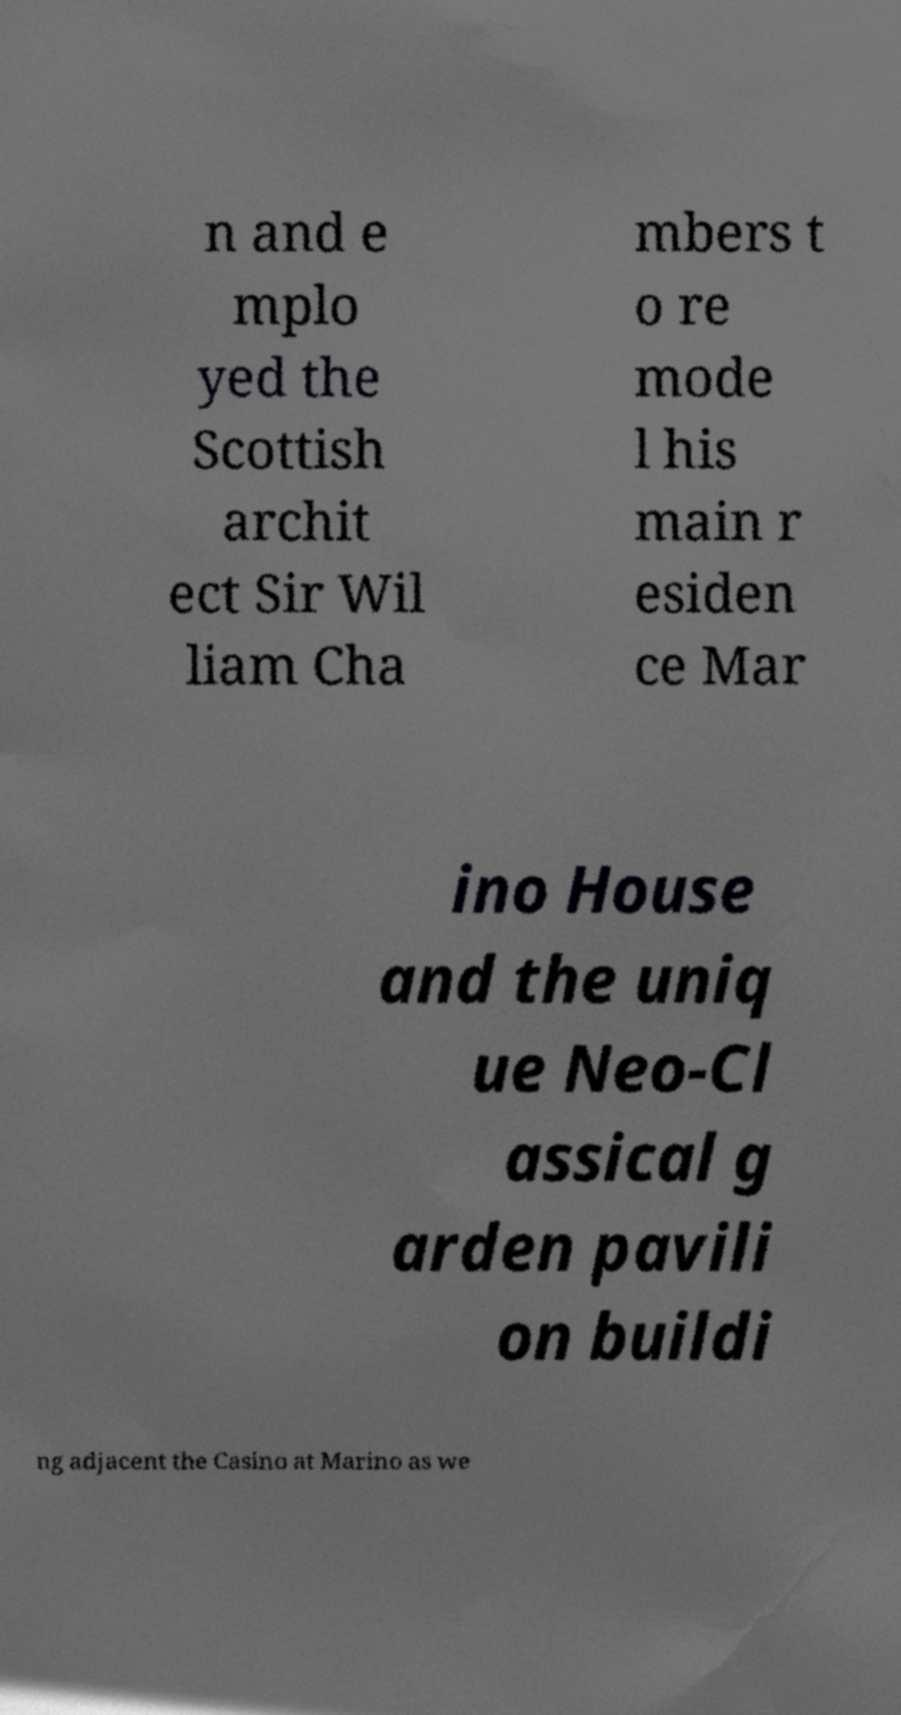There's text embedded in this image that I need extracted. Can you transcribe it verbatim? n and e mplo yed the Scottish archit ect Sir Wil liam Cha mbers t o re mode l his main r esiden ce Mar ino House and the uniq ue Neo-Cl assical g arden pavili on buildi ng adjacent the Casino at Marino as we 